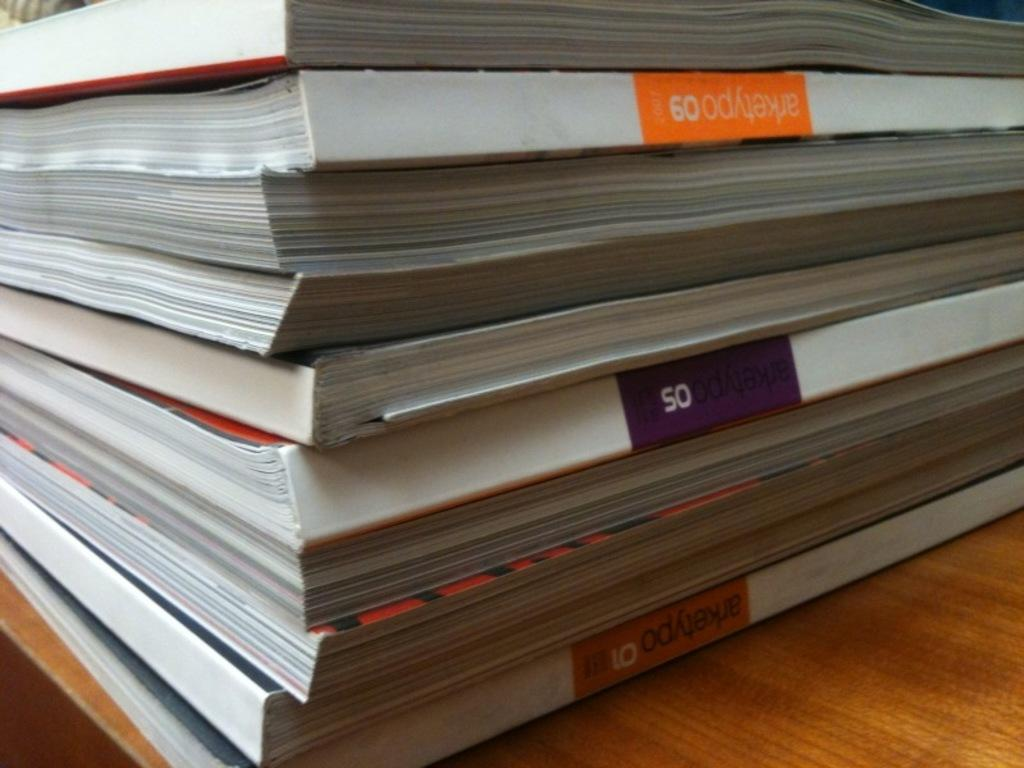<image>
Share a concise interpretation of the image provided. The numbers 50 and 60 are to be seen on the spines of a stack of magazines. 